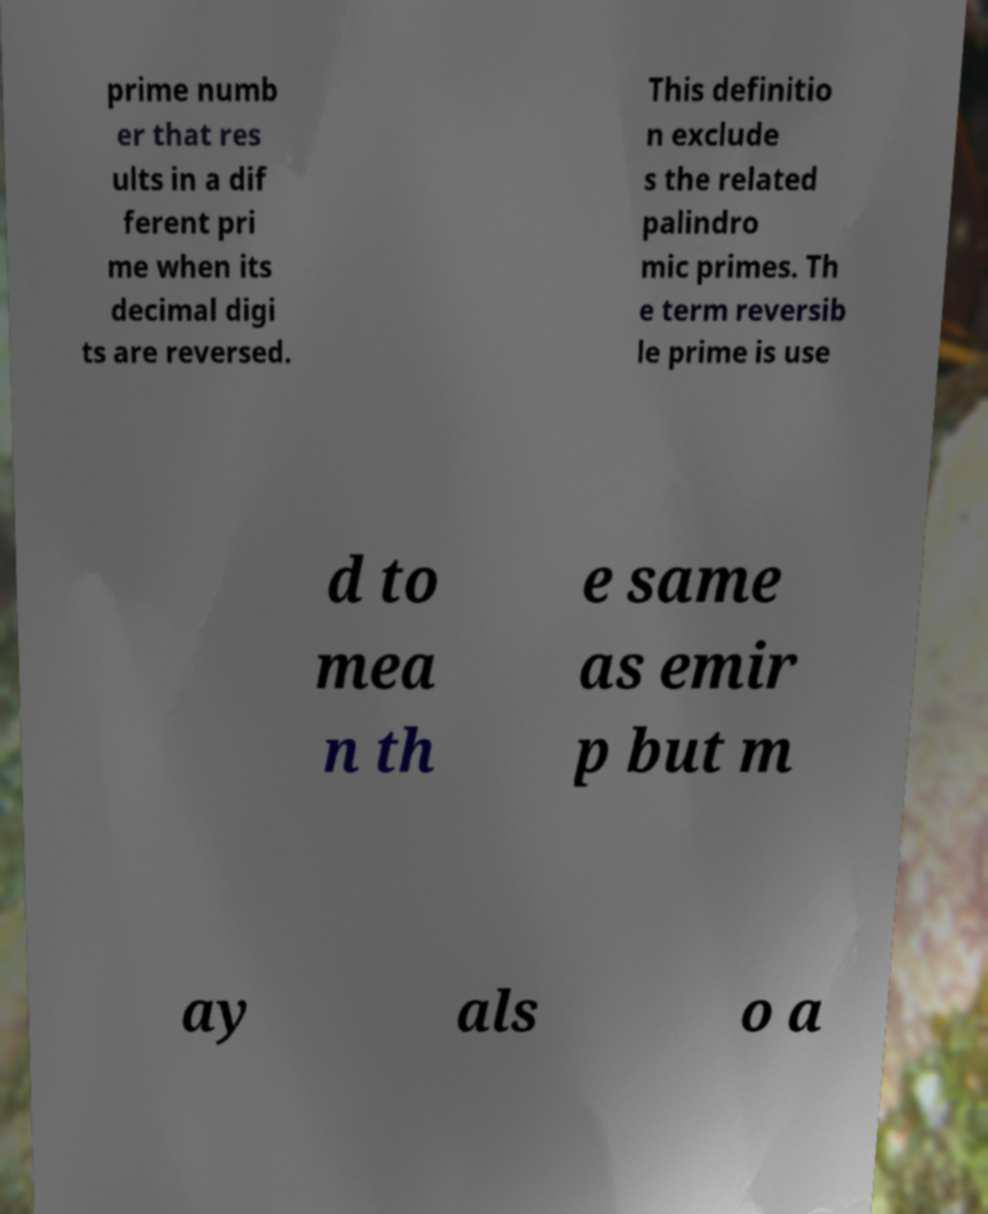For documentation purposes, I need the text within this image transcribed. Could you provide that? prime numb er that res ults in a dif ferent pri me when its decimal digi ts are reversed. This definitio n exclude s the related palindro mic primes. Th e term reversib le prime is use d to mea n th e same as emir p but m ay als o a 